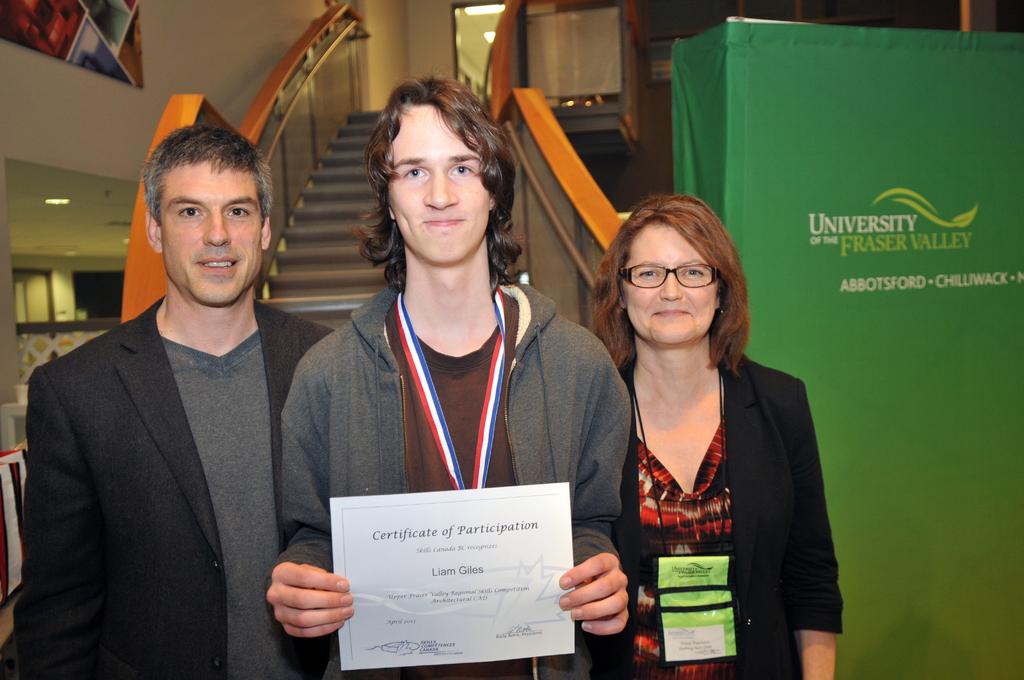What kind of certificate is he holding?
Your answer should be very brief. Participation. 